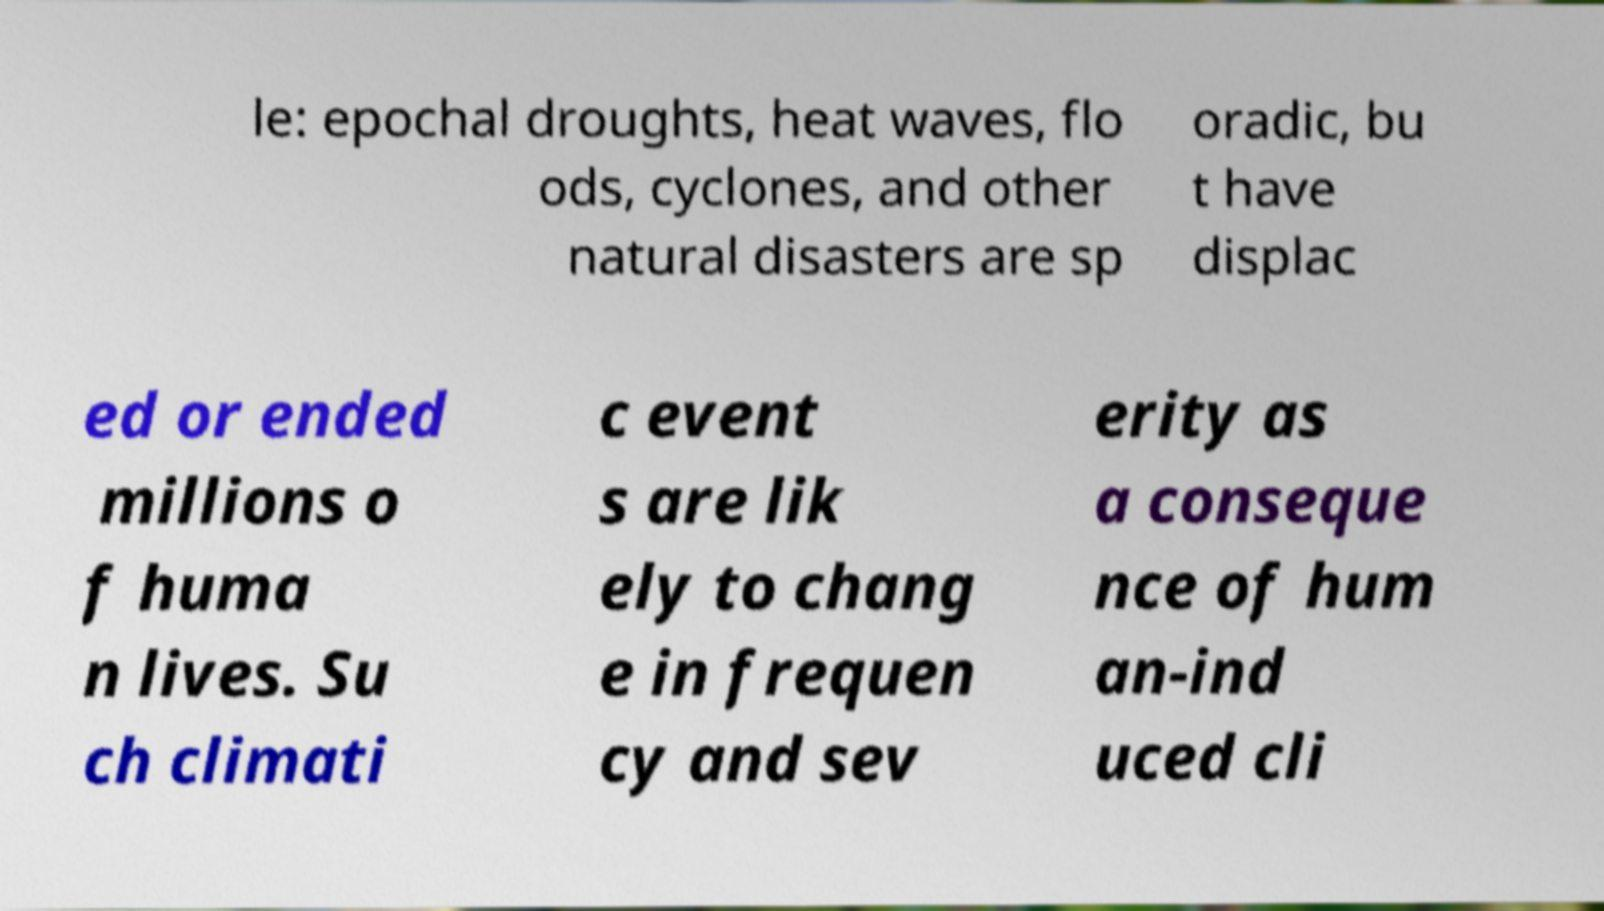There's text embedded in this image that I need extracted. Can you transcribe it verbatim? le: epochal droughts, heat waves, flo ods, cyclones, and other natural disasters are sp oradic, bu t have displac ed or ended millions o f huma n lives. Su ch climati c event s are lik ely to chang e in frequen cy and sev erity as a conseque nce of hum an-ind uced cli 